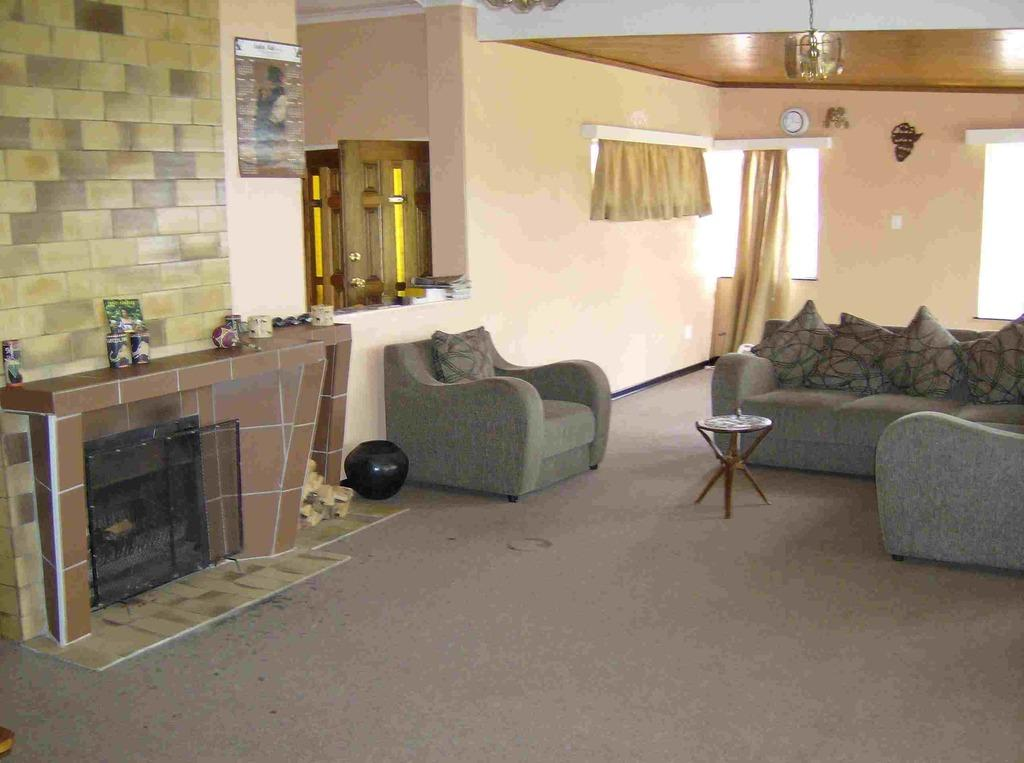What type of furniture is present in the image? There is a sofa set and a table in the image. What can be seen on the walls in the image? There are curtains and a wall visible in the image. What is used for lighting or ventilation in the image? There are windows in the image. What type of government is depicted in the image? There is no depiction of a government in the image; it features a sofa set, a table, curtains, a wall, and windows. Can you smell the pies in the image? There are no pies present in the image, so it is not possible to smell them. 